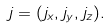Convert formula to latex. <formula><loc_0><loc_0><loc_500><loc_500>j = ( j _ { x } , j _ { y } , j _ { z } ) .</formula> 